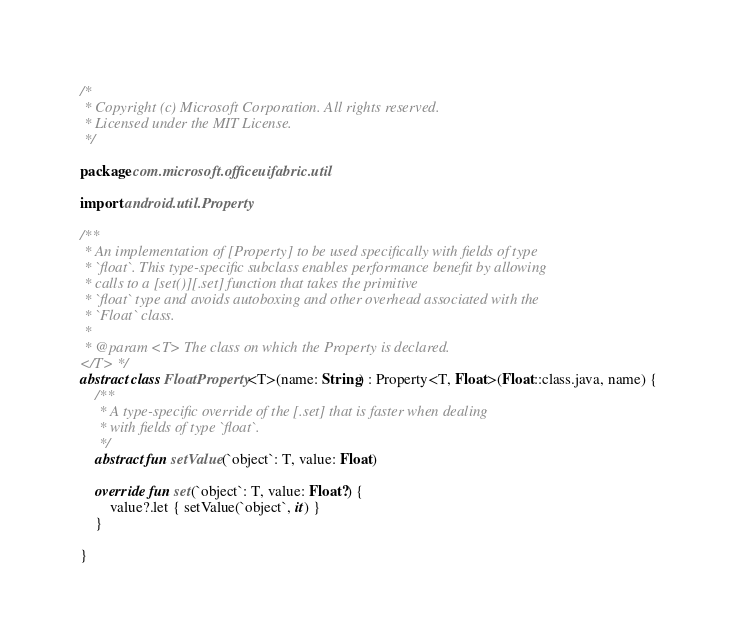<code> <loc_0><loc_0><loc_500><loc_500><_Kotlin_>/*
 * Copyright (c) Microsoft Corporation. All rights reserved.
 * Licensed under the MIT License.
 */

package com.microsoft.officeuifabric.util

import android.util.Property

/**
 * An implementation of [Property] to be used specifically with fields of type
 * `float`. This type-specific subclass enables performance benefit by allowing
 * calls to a [set()][.set] function that takes the primitive
 * `float` type and avoids autoboxing and other overhead associated with the
 * `Float` class.
 *
 * @param <T> The class on which the Property is declared.
</T> */
abstract class FloatProperty<T>(name: String) : Property<T, Float>(Float::class.java, name) {
    /**
     * A type-specific override of the [.set] that is faster when dealing
     * with fields of type `float`.
     */
    abstract fun setValue(`object`: T, value: Float)

    override fun set(`object`: T, value: Float?) {
        value?.let { setValue(`object`, it) }
    }

}</code> 